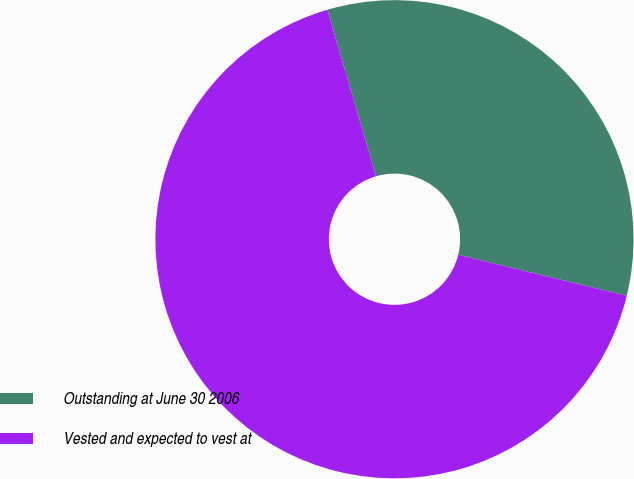Convert chart to OTSL. <chart><loc_0><loc_0><loc_500><loc_500><pie_chart><fcel>Outstanding at June 30 2006<fcel>Vested and expected to vest at<nl><fcel>33.33%<fcel>66.67%<nl></chart> 